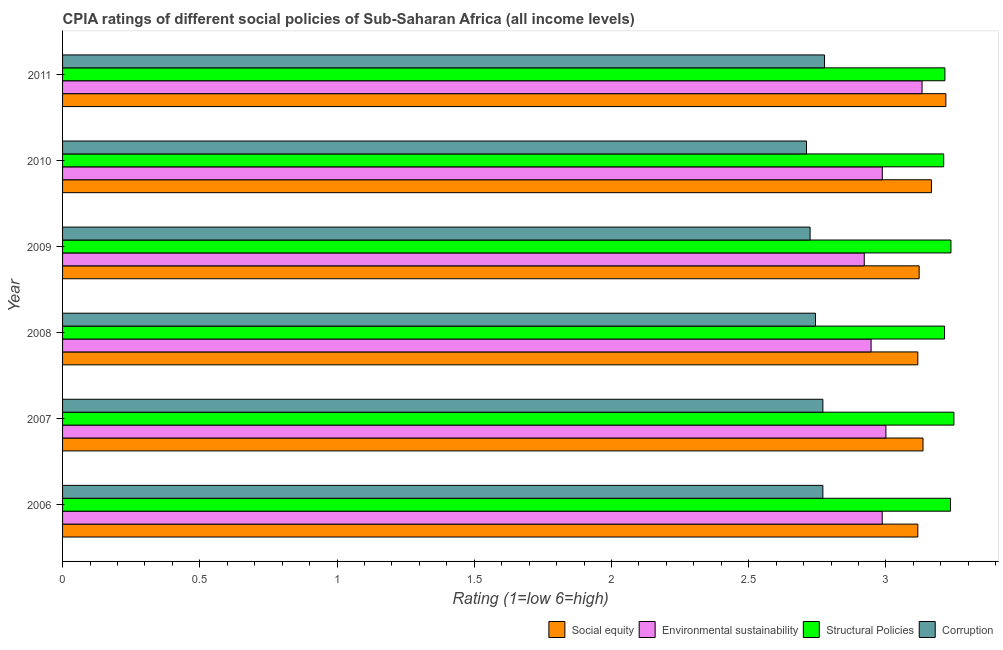How many different coloured bars are there?
Your answer should be very brief. 4. Are the number of bars per tick equal to the number of legend labels?
Provide a succinct answer. Yes. Are the number of bars on each tick of the Y-axis equal?
Give a very brief answer. Yes. How many bars are there on the 3rd tick from the bottom?
Provide a succinct answer. 4. What is the label of the 1st group of bars from the top?
Provide a short and direct response. 2011. In how many cases, is the number of bars for a given year not equal to the number of legend labels?
Your answer should be very brief. 0. What is the cpia rating of corruption in 2009?
Your response must be concise. 2.72. Across all years, what is the maximum cpia rating of social equity?
Provide a short and direct response. 3.22. Across all years, what is the minimum cpia rating of social equity?
Ensure brevity in your answer.  3.12. In which year was the cpia rating of environmental sustainability maximum?
Give a very brief answer. 2011. What is the total cpia rating of corruption in the graph?
Your answer should be very brief. 16.49. What is the difference between the cpia rating of environmental sustainability in 2010 and that in 2011?
Your response must be concise. -0.14. What is the difference between the cpia rating of structural policies in 2009 and the cpia rating of environmental sustainability in 2011?
Offer a terse response. 0.11. What is the average cpia rating of structural policies per year?
Make the answer very short. 3.23. In the year 2009, what is the difference between the cpia rating of social equity and cpia rating of corruption?
Your answer should be compact. 0.4. In how many years, is the cpia rating of corruption greater than 0.5 ?
Offer a very short reply. 6. Is the difference between the cpia rating of structural policies in 2006 and 2007 greater than the difference between the cpia rating of social equity in 2006 and 2007?
Offer a very short reply. Yes. What is the difference between the highest and the second highest cpia rating of social equity?
Ensure brevity in your answer.  0.05. What is the difference between the highest and the lowest cpia rating of social equity?
Your answer should be very brief. 0.1. Is the sum of the cpia rating of environmental sustainability in 2009 and 2011 greater than the maximum cpia rating of structural policies across all years?
Provide a succinct answer. Yes. What does the 1st bar from the top in 2010 represents?
Your response must be concise. Corruption. What does the 4th bar from the bottom in 2008 represents?
Keep it short and to the point. Corruption. How many years are there in the graph?
Provide a succinct answer. 6. What is the difference between two consecutive major ticks on the X-axis?
Your response must be concise. 0.5. Are the values on the major ticks of X-axis written in scientific E-notation?
Keep it short and to the point. No. Does the graph contain grids?
Offer a very short reply. No. Where does the legend appear in the graph?
Keep it short and to the point. Bottom right. How many legend labels are there?
Your response must be concise. 4. How are the legend labels stacked?
Your answer should be compact. Horizontal. What is the title of the graph?
Your answer should be very brief. CPIA ratings of different social policies of Sub-Saharan Africa (all income levels). What is the Rating (1=low 6=high) in Social equity in 2006?
Make the answer very short. 3.12. What is the Rating (1=low 6=high) in Environmental sustainability in 2006?
Your answer should be compact. 2.99. What is the Rating (1=low 6=high) of Structural Policies in 2006?
Make the answer very short. 3.24. What is the Rating (1=low 6=high) of Corruption in 2006?
Give a very brief answer. 2.77. What is the Rating (1=low 6=high) in Social equity in 2007?
Give a very brief answer. 3.14. What is the Rating (1=low 6=high) in Environmental sustainability in 2007?
Give a very brief answer. 3. What is the Rating (1=low 6=high) in Structural Policies in 2007?
Your answer should be compact. 3.25. What is the Rating (1=low 6=high) of Corruption in 2007?
Provide a short and direct response. 2.77. What is the Rating (1=low 6=high) in Social equity in 2008?
Provide a short and direct response. 3.12. What is the Rating (1=low 6=high) of Environmental sustainability in 2008?
Provide a short and direct response. 2.95. What is the Rating (1=low 6=high) of Structural Policies in 2008?
Offer a terse response. 3.21. What is the Rating (1=low 6=high) in Corruption in 2008?
Offer a terse response. 2.74. What is the Rating (1=low 6=high) of Social equity in 2009?
Make the answer very short. 3.12. What is the Rating (1=low 6=high) in Environmental sustainability in 2009?
Ensure brevity in your answer.  2.92. What is the Rating (1=low 6=high) in Structural Policies in 2009?
Your answer should be compact. 3.24. What is the Rating (1=low 6=high) of Corruption in 2009?
Your answer should be very brief. 2.72. What is the Rating (1=low 6=high) of Social equity in 2010?
Provide a succinct answer. 3.17. What is the Rating (1=low 6=high) in Environmental sustainability in 2010?
Your answer should be compact. 2.99. What is the Rating (1=low 6=high) of Structural Policies in 2010?
Offer a terse response. 3.21. What is the Rating (1=low 6=high) in Corruption in 2010?
Make the answer very short. 2.71. What is the Rating (1=low 6=high) in Social equity in 2011?
Your answer should be very brief. 3.22. What is the Rating (1=low 6=high) in Environmental sustainability in 2011?
Make the answer very short. 3.13. What is the Rating (1=low 6=high) of Structural Policies in 2011?
Your answer should be very brief. 3.21. What is the Rating (1=low 6=high) of Corruption in 2011?
Ensure brevity in your answer.  2.78. Across all years, what is the maximum Rating (1=low 6=high) in Social equity?
Ensure brevity in your answer.  3.22. Across all years, what is the maximum Rating (1=low 6=high) of Environmental sustainability?
Offer a terse response. 3.13. Across all years, what is the maximum Rating (1=low 6=high) in Structural Policies?
Give a very brief answer. 3.25. Across all years, what is the maximum Rating (1=low 6=high) in Corruption?
Give a very brief answer. 2.78. Across all years, what is the minimum Rating (1=low 6=high) of Social equity?
Ensure brevity in your answer.  3.12. Across all years, what is the minimum Rating (1=low 6=high) of Environmental sustainability?
Provide a short and direct response. 2.92. Across all years, what is the minimum Rating (1=low 6=high) of Structural Policies?
Offer a terse response. 3.21. Across all years, what is the minimum Rating (1=low 6=high) in Corruption?
Offer a terse response. 2.71. What is the total Rating (1=low 6=high) of Social equity in the graph?
Ensure brevity in your answer.  18.87. What is the total Rating (1=low 6=high) in Environmental sustainability in the graph?
Provide a succinct answer. 17.97. What is the total Rating (1=low 6=high) in Structural Policies in the graph?
Make the answer very short. 19.36. What is the total Rating (1=low 6=high) in Corruption in the graph?
Your response must be concise. 16.49. What is the difference between the Rating (1=low 6=high) of Social equity in 2006 and that in 2007?
Keep it short and to the point. -0.02. What is the difference between the Rating (1=low 6=high) of Environmental sustainability in 2006 and that in 2007?
Offer a very short reply. -0.01. What is the difference between the Rating (1=low 6=high) of Structural Policies in 2006 and that in 2007?
Keep it short and to the point. -0.01. What is the difference between the Rating (1=low 6=high) of Corruption in 2006 and that in 2007?
Provide a succinct answer. 0. What is the difference between the Rating (1=low 6=high) of Environmental sustainability in 2006 and that in 2008?
Offer a terse response. 0.04. What is the difference between the Rating (1=low 6=high) of Structural Policies in 2006 and that in 2008?
Provide a succinct answer. 0.02. What is the difference between the Rating (1=low 6=high) of Corruption in 2006 and that in 2008?
Keep it short and to the point. 0.03. What is the difference between the Rating (1=low 6=high) in Social equity in 2006 and that in 2009?
Your response must be concise. -0. What is the difference between the Rating (1=low 6=high) in Environmental sustainability in 2006 and that in 2009?
Offer a terse response. 0.07. What is the difference between the Rating (1=low 6=high) in Structural Policies in 2006 and that in 2009?
Your answer should be compact. -0. What is the difference between the Rating (1=low 6=high) of Corruption in 2006 and that in 2009?
Ensure brevity in your answer.  0.05. What is the difference between the Rating (1=low 6=high) of Social equity in 2006 and that in 2010?
Ensure brevity in your answer.  -0.05. What is the difference between the Rating (1=low 6=high) of Environmental sustainability in 2006 and that in 2010?
Keep it short and to the point. -0. What is the difference between the Rating (1=low 6=high) of Structural Policies in 2006 and that in 2010?
Your answer should be compact. 0.02. What is the difference between the Rating (1=low 6=high) of Corruption in 2006 and that in 2010?
Ensure brevity in your answer.  0.06. What is the difference between the Rating (1=low 6=high) of Social equity in 2006 and that in 2011?
Your response must be concise. -0.1. What is the difference between the Rating (1=low 6=high) of Environmental sustainability in 2006 and that in 2011?
Make the answer very short. -0.15. What is the difference between the Rating (1=low 6=high) in Structural Policies in 2006 and that in 2011?
Provide a short and direct response. 0.02. What is the difference between the Rating (1=low 6=high) in Corruption in 2006 and that in 2011?
Offer a terse response. -0.01. What is the difference between the Rating (1=low 6=high) of Social equity in 2007 and that in 2008?
Provide a short and direct response. 0.02. What is the difference between the Rating (1=low 6=high) of Environmental sustainability in 2007 and that in 2008?
Your response must be concise. 0.05. What is the difference between the Rating (1=low 6=high) in Structural Policies in 2007 and that in 2008?
Your response must be concise. 0.03. What is the difference between the Rating (1=low 6=high) of Corruption in 2007 and that in 2008?
Your answer should be compact. 0.03. What is the difference between the Rating (1=low 6=high) of Social equity in 2007 and that in 2009?
Ensure brevity in your answer.  0.01. What is the difference between the Rating (1=low 6=high) in Environmental sustainability in 2007 and that in 2009?
Give a very brief answer. 0.08. What is the difference between the Rating (1=low 6=high) in Structural Policies in 2007 and that in 2009?
Ensure brevity in your answer.  0.01. What is the difference between the Rating (1=low 6=high) in Corruption in 2007 and that in 2009?
Ensure brevity in your answer.  0.05. What is the difference between the Rating (1=low 6=high) of Social equity in 2007 and that in 2010?
Offer a very short reply. -0.03. What is the difference between the Rating (1=low 6=high) of Environmental sustainability in 2007 and that in 2010?
Your response must be concise. 0.01. What is the difference between the Rating (1=low 6=high) in Structural Policies in 2007 and that in 2010?
Provide a succinct answer. 0.04. What is the difference between the Rating (1=low 6=high) in Corruption in 2007 and that in 2010?
Your response must be concise. 0.06. What is the difference between the Rating (1=low 6=high) of Social equity in 2007 and that in 2011?
Offer a terse response. -0.08. What is the difference between the Rating (1=low 6=high) in Environmental sustainability in 2007 and that in 2011?
Ensure brevity in your answer.  -0.13. What is the difference between the Rating (1=low 6=high) of Structural Policies in 2007 and that in 2011?
Your response must be concise. 0.03. What is the difference between the Rating (1=low 6=high) of Corruption in 2007 and that in 2011?
Provide a succinct answer. -0.01. What is the difference between the Rating (1=low 6=high) of Social equity in 2008 and that in 2009?
Your answer should be very brief. -0. What is the difference between the Rating (1=low 6=high) of Environmental sustainability in 2008 and that in 2009?
Offer a very short reply. 0.02. What is the difference between the Rating (1=low 6=high) in Structural Policies in 2008 and that in 2009?
Offer a terse response. -0.02. What is the difference between the Rating (1=low 6=high) of Corruption in 2008 and that in 2009?
Keep it short and to the point. 0.02. What is the difference between the Rating (1=low 6=high) of Social equity in 2008 and that in 2010?
Offer a terse response. -0.05. What is the difference between the Rating (1=low 6=high) of Environmental sustainability in 2008 and that in 2010?
Give a very brief answer. -0.04. What is the difference between the Rating (1=low 6=high) of Structural Policies in 2008 and that in 2010?
Keep it short and to the point. 0. What is the difference between the Rating (1=low 6=high) in Corruption in 2008 and that in 2010?
Give a very brief answer. 0.03. What is the difference between the Rating (1=low 6=high) of Social equity in 2008 and that in 2011?
Ensure brevity in your answer.  -0.1. What is the difference between the Rating (1=low 6=high) in Environmental sustainability in 2008 and that in 2011?
Provide a short and direct response. -0.19. What is the difference between the Rating (1=low 6=high) in Structural Policies in 2008 and that in 2011?
Give a very brief answer. -0. What is the difference between the Rating (1=low 6=high) in Corruption in 2008 and that in 2011?
Offer a very short reply. -0.03. What is the difference between the Rating (1=low 6=high) in Social equity in 2009 and that in 2010?
Your response must be concise. -0.04. What is the difference between the Rating (1=low 6=high) of Environmental sustainability in 2009 and that in 2010?
Offer a very short reply. -0.07. What is the difference between the Rating (1=low 6=high) of Structural Policies in 2009 and that in 2010?
Ensure brevity in your answer.  0.03. What is the difference between the Rating (1=low 6=high) of Corruption in 2009 and that in 2010?
Keep it short and to the point. 0.01. What is the difference between the Rating (1=low 6=high) of Social equity in 2009 and that in 2011?
Provide a succinct answer. -0.1. What is the difference between the Rating (1=low 6=high) in Environmental sustainability in 2009 and that in 2011?
Your answer should be very brief. -0.21. What is the difference between the Rating (1=low 6=high) in Structural Policies in 2009 and that in 2011?
Your answer should be compact. 0.02. What is the difference between the Rating (1=low 6=high) in Corruption in 2009 and that in 2011?
Your answer should be compact. -0.05. What is the difference between the Rating (1=low 6=high) in Social equity in 2010 and that in 2011?
Your response must be concise. -0.05. What is the difference between the Rating (1=low 6=high) in Environmental sustainability in 2010 and that in 2011?
Provide a short and direct response. -0.14. What is the difference between the Rating (1=low 6=high) in Structural Policies in 2010 and that in 2011?
Give a very brief answer. -0. What is the difference between the Rating (1=low 6=high) of Corruption in 2010 and that in 2011?
Give a very brief answer. -0.07. What is the difference between the Rating (1=low 6=high) in Social equity in 2006 and the Rating (1=low 6=high) in Environmental sustainability in 2007?
Provide a short and direct response. 0.12. What is the difference between the Rating (1=low 6=high) of Social equity in 2006 and the Rating (1=low 6=high) of Structural Policies in 2007?
Ensure brevity in your answer.  -0.13. What is the difference between the Rating (1=low 6=high) of Social equity in 2006 and the Rating (1=low 6=high) of Corruption in 2007?
Ensure brevity in your answer.  0.35. What is the difference between the Rating (1=low 6=high) in Environmental sustainability in 2006 and the Rating (1=low 6=high) in Structural Policies in 2007?
Your answer should be very brief. -0.26. What is the difference between the Rating (1=low 6=high) in Environmental sustainability in 2006 and the Rating (1=low 6=high) in Corruption in 2007?
Provide a short and direct response. 0.22. What is the difference between the Rating (1=low 6=high) in Structural Policies in 2006 and the Rating (1=low 6=high) in Corruption in 2007?
Give a very brief answer. 0.46. What is the difference between the Rating (1=low 6=high) of Social equity in 2006 and the Rating (1=low 6=high) of Environmental sustainability in 2008?
Offer a very short reply. 0.17. What is the difference between the Rating (1=low 6=high) of Social equity in 2006 and the Rating (1=low 6=high) of Structural Policies in 2008?
Your answer should be compact. -0.1. What is the difference between the Rating (1=low 6=high) of Social equity in 2006 and the Rating (1=low 6=high) of Corruption in 2008?
Ensure brevity in your answer.  0.37. What is the difference between the Rating (1=low 6=high) of Environmental sustainability in 2006 and the Rating (1=low 6=high) of Structural Policies in 2008?
Ensure brevity in your answer.  -0.23. What is the difference between the Rating (1=low 6=high) in Environmental sustainability in 2006 and the Rating (1=low 6=high) in Corruption in 2008?
Your answer should be very brief. 0.24. What is the difference between the Rating (1=low 6=high) of Structural Policies in 2006 and the Rating (1=low 6=high) of Corruption in 2008?
Provide a succinct answer. 0.49. What is the difference between the Rating (1=low 6=high) in Social equity in 2006 and the Rating (1=low 6=high) in Environmental sustainability in 2009?
Ensure brevity in your answer.  0.2. What is the difference between the Rating (1=low 6=high) in Social equity in 2006 and the Rating (1=low 6=high) in Structural Policies in 2009?
Ensure brevity in your answer.  -0.12. What is the difference between the Rating (1=low 6=high) of Social equity in 2006 and the Rating (1=low 6=high) of Corruption in 2009?
Give a very brief answer. 0.39. What is the difference between the Rating (1=low 6=high) in Environmental sustainability in 2006 and the Rating (1=low 6=high) in Structural Policies in 2009?
Ensure brevity in your answer.  -0.25. What is the difference between the Rating (1=low 6=high) of Environmental sustainability in 2006 and the Rating (1=low 6=high) of Corruption in 2009?
Ensure brevity in your answer.  0.26. What is the difference between the Rating (1=low 6=high) of Structural Policies in 2006 and the Rating (1=low 6=high) of Corruption in 2009?
Offer a very short reply. 0.51. What is the difference between the Rating (1=low 6=high) in Social equity in 2006 and the Rating (1=low 6=high) in Environmental sustainability in 2010?
Keep it short and to the point. 0.13. What is the difference between the Rating (1=low 6=high) of Social equity in 2006 and the Rating (1=low 6=high) of Structural Policies in 2010?
Make the answer very short. -0.09. What is the difference between the Rating (1=low 6=high) of Social equity in 2006 and the Rating (1=low 6=high) of Corruption in 2010?
Your answer should be compact. 0.41. What is the difference between the Rating (1=low 6=high) of Environmental sustainability in 2006 and the Rating (1=low 6=high) of Structural Policies in 2010?
Ensure brevity in your answer.  -0.22. What is the difference between the Rating (1=low 6=high) in Environmental sustainability in 2006 and the Rating (1=low 6=high) in Corruption in 2010?
Give a very brief answer. 0.28. What is the difference between the Rating (1=low 6=high) of Structural Policies in 2006 and the Rating (1=low 6=high) of Corruption in 2010?
Your answer should be compact. 0.52. What is the difference between the Rating (1=low 6=high) in Social equity in 2006 and the Rating (1=low 6=high) in Environmental sustainability in 2011?
Your response must be concise. -0.02. What is the difference between the Rating (1=low 6=high) of Social equity in 2006 and the Rating (1=low 6=high) of Structural Policies in 2011?
Make the answer very short. -0.1. What is the difference between the Rating (1=low 6=high) in Social equity in 2006 and the Rating (1=low 6=high) in Corruption in 2011?
Ensure brevity in your answer.  0.34. What is the difference between the Rating (1=low 6=high) of Environmental sustainability in 2006 and the Rating (1=low 6=high) of Structural Policies in 2011?
Keep it short and to the point. -0.23. What is the difference between the Rating (1=low 6=high) in Environmental sustainability in 2006 and the Rating (1=low 6=high) in Corruption in 2011?
Offer a terse response. 0.21. What is the difference between the Rating (1=low 6=high) in Structural Policies in 2006 and the Rating (1=low 6=high) in Corruption in 2011?
Provide a short and direct response. 0.46. What is the difference between the Rating (1=low 6=high) of Social equity in 2007 and the Rating (1=low 6=high) of Environmental sustainability in 2008?
Offer a terse response. 0.19. What is the difference between the Rating (1=low 6=high) in Social equity in 2007 and the Rating (1=low 6=high) in Structural Policies in 2008?
Provide a succinct answer. -0.08. What is the difference between the Rating (1=low 6=high) of Social equity in 2007 and the Rating (1=low 6=high) of Corruption in 2008?
Provide a succinct answer. 0.39. What is the difference between the Rating (1=low 6=high) of Environmental sustainability in 2007 and the Rating (1=low 6=high) of Structural Policies in 2008?
Keep it short and to the point. -0.21. What is the difference between the Rating (1=low 6=high) of Environmental sustainability in 2007 and the Rating (1=low 6=high) of Corruption in 2008?
Your response must be concise. 0.26. What is the difference between the Rating (1=low 6=high) of Structural Policies in 2007 and the Rating (1=low 6=high) of Corruption in 2008?
Provide a succinct answer. 0.5. What is the difference between the Rating (1=low 6=high) in Social equity in 2007 and the Rating (1=low 6=high) in Environmental sustainability in 2009?
Your answer should be compact. 0.21. What is the difference between the Rating (1=low 6=high) in Social equity in 2007 and the Rating (1=low 6=high) in Structural Policies in 2009?
Your answer should be compact. -0.1. What is the difference between the Rating (1=low 6=high) of Social equity in 2007 and the Rating (1=low 6=high) of Corruption in 2009?
Your answer should be compact. 0.41. What is the difference between the Rating (1=low 6=high) of Environmental sustainability in 2007 and the Rating (1=low 6=high) of Structural Policies in 2009?
Your answer should be very brief. -0.24. What is the difference between the Rating (1=low 6=high) of Environmental sustainability in 2007 and the Rating (1=low 6=high) of Corruption in 2009?
Your answer should be very brief. 0.28. What is the difference between the Rating (1=low 6=high) of Structural Policies in 2007 and the Rating (1=low 6=high) of Corruption in 2009?
Offer a very short reply. 0.52. What is the difference between the Rating (1=low 6=high) in Social equity in 2007 and the Rating (1=low 6=high) in Environmental sustainability in 2010?
Your response must be concise. 0.15. What is the difference between the Rating (1=low 6=high) in Social equity in 2007 and the Rating (1=low 6=high) in Structural Policies in 2010?
Provide a short and direct response. -0.08. What is the difference between the Rating (1=low 6=high) in Social equity in 2007 and the Rating (1=low 6=high) in Corruption in 2010?
Make the answer very short. 0.42. What is the difference between the Rating (1=low 6=high) in Environmental sustainability in 2007 and the Rating (1=low 6=high) in Structural Policies in 2010?
Keep it short and to the point. -0.21. What is the difference between the Rating (1=low 6=high) of Environmental sustainability in 2007 and the Rating (1=low 6=high) of Corruption in 2010?
Ensure brevity in your answer.  0.29. What is the difference between the Rating (1=low 6=high) in Structural Policies in 2007 and the Rating (1=low 6=high) in Corruption in 2010?
Offer a very short reply. 0.54. What is the difference between the Rating (1=low 6=high) in Social equity in 2007 and the Rating (1=low 6=high) in Environmental sustainability in 2011?
Make the answer very short. 0. What is the difference between the Rating (1=low 6=high) in Social equity in 2007 and the Rating (1=low 6=high) in Structural Policies in 2011?
Give a very brief answer. -0.08. What is the difference between the Rating (1=low 6=high) in Social equity in 2007 and the Rating (1=low 6=high) in Corruption in 2011?
Your answer should be very brief. 0.36. What is the difference between the Rating (1=low 6=high) in Environmental sustainability in 2007 and the Rating (1=low 6=high) in Structural Policies in 2011?
Offer a very short reply. -0.21. What is the difference between the Rating (1=low 6=high) of Environmental sustainability in 2007 and the Rating (1=low 6=high) of Corruption in 2011?
Provide a short and direct response. 0.22. What is the difference between the Rating (1=low 6=high) in Structural Policies in 2007 and the Rating (1=low 6=high) in Corruption in 2011?
Give a very brief answer. 0.47. What is the difference between the Rating (1=low 6=high) in Social equity in 2008 and the Rating (1=low 6=high) in Environmental sustainability in 2009?
Offer a terse response. 0.2. What is the difference between the Rating (1=low 6=high) in Social equity in 2008 and the Rating (1=low 6=high) in Structural Policies in 2009?
Offer a terse response. -0.12. What is the difference between the Rating (1=low 6=high) in Social equity in 2008 and the Rating (1=low 6=high) in Corruption in 2009?
Provide a succinct answer. 0.39. What is the difference between the Rating (1=low 6=high) in Environmental sustainability in 2008 and the Rating (1=low 6=high) in Structural Policies in 2009?
Your answer should be very brief. -0.29. What is the difference between the Rating (1=low 6=high) of Environmental sustainability in 2008 and the Rating (1=low 6=high) of Corruption in 2009?
Give a very brief answer. 0.22. What is the difference between the Rating (1=low 6=high) of Structural Policies in 2008 and the Rating (1=low 6=high) of Corruption in 2009?
Make the answer very short. 0.49. What is the difference between the Rating (1=low 6=high) in Social equity in 2008 and the Rating (1=low 6=high) in Environmental sustainability in 2010?
Ensure brevity in your answer.  0.13. What is the difference between the Rating (1=low 6=high) in Social equity in 2008 and the Rating (1=low 6=high) in Structural Policies in 2010?
Offer a terse response. -0.09. What is the difference between the Rating (1=low 6=high) of Social equity in 2008 and the Rating (1=low 6=high) of Corruption in 2010?
Your response must be concise. 0.41. What is the difference between the Rating (1=low 6=high) in Environmental sustainability in 2008 and the Rating (1=low 6=high) in Structural Policies in 2010?
Your answer should be very brief. -0.26. What is the difference between the Rating (1=low 6=high) in Environmental sustainability in 2008 and the Rating (1=low 6=high) in Corruption in 2010?
Give a very brief answer. 0.24. What is the difference between the Rating (1=low 6=high) in Structural Policies in 2008 and the Rating (1=low 6=high) in Corruption in 2010?
Your answer should be compact. 0.5. What is the difference between the Rating (1=low 6=high) of Social equity in 2008 and the Rating (1=low 6=high) of Environmental sustainability in 2011?
Keep it short and to the point. -0.02. What is the difference between the Rating (1=low 6=high) of Social equity in 2008 and the Rating (1=low 6=high) of Structural Policies in 2011?
Offer a very short reply. -0.1. What is the difference between the Rating (1=low 6=high) in Social equity in 2008 and the Rating (1=low 6=high) in Corruption in 2011?
Your response must be concise. 0.34. What is the difference between the Rating (1=low 6=high) in Environmental sustainability in 2008 and the Rating (1=low 6=high) in Structural Policies in 2011?
Provide a short and direct response. -0.27. What is the difference between the Rating (1=low 6=high) in Environmental sustainability in 2008 and the Rating (1=low 6=high) in Corruption in 2011?
Ensure brevity in your answer.  0.17. What is the difference between the Rating (1=low 6=high) in Structural Policies in 2008 and the Rating (1=low 6=high) in Corruption in 2011?
Offer a terse response. 0.44. What is the difference between the Rating (1=low 6=high) of Social equity in 2009 and the Rating (1=low 6=high) of Environmental sustainability in 2010?
Your response must be concise. 0.13. What is the difference between the Rating (1=low 6=high) of Social equity in 2009 and the Rating (1=low 6=high) of Structural Policies in 2010?
Provide a short and direct response. -0.09. What is the difference between the Rating (1=low 6=high) of Social equity in 2009 and the Rating (1=low 6=high) of Corruption in 2010?
Provide a succinct answer. 0.41. What is the difference between the Rating (1=low 6=high) in Environmental sustainability in 2009 and the Rating (1=low 6=high) in Structural Policies in 2010?
Provide a succinct answer. -0.29. What is the difference between the Rating (1=low 6=high) of Environmental sustainability in 2009 and the Rating (1=low 6=high) of Corruption in 2010?
Your response must be concise. 0.21. What is the difference between the Rating (1=low 6=high) of Structural Policies in 2009 and the Rating (1=low 6=high) of Corruption in 2010?
Provide a succinct answer. 0.53. What is the difference between the Rating (1=low 6=high) in Social equity in 2009 and the Rating (1=low 6=high) in Environmental sustainability in 2011?
Make the answer very short. -0.01. What is the difference between the Rating (1=low 6=high) of Social equity in 2009 and the Rating (1=low 6=high) of Structural Policies in 2011?
Your answer should be compact. -0.09. What is the difference between the Rating (1=low 6=high) in Social equity in 2009 and the Rating (1=low 6=high) in Corruption in 2011?
Offer a terse response. 0.34. What is the difference between the Rating (1=low 6=high) in Environmental sustainability in 2009 and the Rating (1=low 6=high) in Structural Policies in 2011?
Your answer should be very brief. -0.29. What is the difference between the Rating (1=low 6=high) in Environmental sustainability in 2009 and the Rating (1=low 6=high) in Corruption in 2011?
Your answer should be very brief. 0.14. What is the difference between the Rating (1=low 6=high) in Structural Policies in 2009 and the Rating (1=low 6=high) in Corruption in 2011?
Provide a succinct answer. 0.46. What is the difference between the Rating (1=low 6=high) of Social equity in 2010 and the Rating (1=low 6=high) of Environmental sustainability in 2011?
Offer a very short reply. 0.03. What is the difference between the Rating (1=low 6=high) of Social equity in 2010 and the Rating (1=low 6=high) of Structural Policies in 2011?
Provide a succinct answer. -0.05. What is the difference between the Rating (1=low 6=high) in Social equity in 2010 and the Rating (1=low 6=high) in Corruption in 2011?
Provide a short and direct response. 0.39. What is the difference between the Rating (1=low 6=high) of Environmental sustainability in 2010 and the Rating (1=low 6=high) of Structural Policies in 2011?
Provide a short and direct response. -0.23. What is the difference between the Rating (1=low 6=high) of Environmental sustainability in 2010 and the Rating (1=low 6=high) of Corruption in 2011?
Provide a succinct answer. 0.21. What is the difference between the Rating (1=low 6=high) of Structural Policies in 2010 and the Rating (1=low 6=high) of Corruption in 2011?
Ensure brevity in your answer.  0.43. What is the average Rating (1=low 6=high) in Social equity per year?
Your response must be concise. 3.15. What is the average Rating (1=low 6=high) of Environmental sustainability per year?
Provide a short and direct response. 3. What is the average Rating (1=low 6=high) of Structural Policies per year?
Provide a succinct answer. 3.23. What is the average Rating (1=low 6=high) of Corruption per year?
Your answer should be compact. 2.75. In the year 2006, what is the difference between the Rating (1=low 6=high) in Social equity and Rating (1=low 6=high) in Environmental sustainability?
Offer a terse response. 0.13. In the year 2006, what is the difference between the Rating (1=low 6=high) in Social equity and Rating (1=low 6=high) in Structural Policies?
Give a very brief answer. -0.12. In the year 2006, what is the difference between the Rating (1=low 6=high) in Social equity and Rating (1=low 6=high) in Corruption?
Your response must be concise. 0.35. In the year 2006, what is the difference between the Rating (1=low 6=high) of Environmental sustainability and Rating (1=low 6=high) of Structural Policies?
Your response must be concise. -0.25. In the year 2006, what is the difference between the Rating (1=low 6=high) in Environmental sustainability and Rating (1=low 6=high) in Corruption?
Provide a succinct answer. 0.22. In the year 2006, what is the difference between the Rating (1=low 6=high) of Structural Policies and Rating (1=low 6=high) of Corruption?
Provide a short and direct response. 0.46. In the year 2007, what is the difference between the Rating (1=low 6=high) in Social equity and Rating (1=low 6=high) in Environmental sustainability?
Offer a terse response. 0.14. In the year 2007, what is the difference between the Rating (1=low 6=high) in Social equity and Rating (1=low 6=high) in Structural Policies?
Your answer should be very brief. -0.11. In the year 2007, what is the difference between the Rating (1=low 6=high) in Social equity and Rating (1=low 6=high) in Corruption?
Provide a succinct answer. 0.36. In the year 2007, what is the difference between the Rating (1=low 6=high) in Environmental sustainability and Rating (1=low 6=high) in Structural Policies?
Ensure brevity in your answer.  -0.25. In the year 2007, what is the difference between the Rating (1=low 6=high) in Environmental sustainability and Rating (1=low 6=high) in Corruption?
Your answer should be compact. 0.23. In the year 2007, what is the difference between the Rating (1=low 6=high) of Structural Policies and Rating (1=low 6=high) of Corruption?
Keep it short and to the point. 0.48. In the year 2008, what is the difference between the Rating (1=low 6=high) of Social equity and Rating (1=low 6=high) of Environmental sustainability?
Provide a short and direct response. 0.17. In the year 2008, what is the difference between the Rating (1=low 6=high) of Social equity and Rating (1=low 6=high) of Structural Policies?
Give a very brief answer. -0.1. In the year 2008, what is the difference between the Rating (1=low 6=high) in Social equity and Rating (1=low 6=high) in Corruption?
Give a very brief answer. 0.37. In the year 2008, what is the difference between the Rating (1=low 6=high) in Environmental sustainability and Rating (1=low 6=high) in Structural Policies?
Provide a short and direct response. -0.27. In the year 2008, what is the difference between the Rating (1=low 6=high) of Environmental sustainability and Rating (1=low 6=high) of Corruption?
Provide a short and direct response. 0.2. In the year 2008, what is the difference between the Rating (1=low 6=high) of Structural Policies and Rating (1=low 6=high) of Corruption?
Provide a succinct answer. 0.47. In the year 2009, what is the difference between the Rating (1=low 6=high) of Social equity and Rating (1=low 6=high) of Environmental sustainability?
Your response must be concise. 0.2. In the year 2009, what is the difference between the Rating (1=low 6=high) of Social equity and Rating (1=low 6=high) of Structural Policies?
Your answer should be compact. -0.12. In the year 2009, what is the difference between the Rating (1=low 6=high) in Social equity and Rating (1=low 6=high) in Corruption?
Provide a short and direct response. 0.4. In the year 2009, what is the difference between the Rating (1=low 6=high) in Environmental sustainability and Rating (1=low 6=high) in Structural Policies?
Provide a short and direct response. -0.32. In the year 2009, what is the difference between the Rating (1=low 6=high) of Environmental sustainability and Rating (1=low 6=high) of Corruption?
Give a very brief answer. 0.2. In the year 2009, what is the difference between the Rating (1=low 6=high) in Structural Policies and Rating (1=low 6=high) in Corruption?
Make the answer very short. 0.51. In the year 2010, what is the difference between the Rating (1=low 6=high) in Social equity and Rating (1=low 6=high) in Environmental sustainability?
Your answer should be very brief. 0.18. In the year 2010, what is the difference between the Rating (1=low 6=high) of Social equity and Rating (1=low 6=high) of Structural Policies?
Offer a very short reply. -0.04. In the year 2010, what is the difference between the Rating (1=low 6=high) in Social equity and Rating (1=low 6=high) in Corruption?
Your answer should be very brief. 0.46. In the year 2010, what is the difference between the Rating (1=low 6=high) of Environmental sustainability and Rating (1=low 6=high) of Structural Policies?
Provide a succinct answer. -0.22. In the year 2010, what is the difference between the Rating (1=low 6=high) of Environmental sustainability and Rating (1=low 6=high) of Corruption?
Your response must be concise. 0.28. In the year 2010, what is the difference between the Rating (1=low 6=high) of Structural Policies and Rating (1=low 6=high) of Corruption?
Keep it short and to the point. 0.5. In the year 2011, what is the difference between the Rating (1=low 6=high) in Social equity and Rating (1=low 6=high) in Environmental sustainability?
Provide a short and direct response. 0.09. In the year 2011, what is the difference between the Rating (1=low 6=high) of Social equity and Rating (1=low 6=high) of Structural Policies?
Keep it short and to the point. 0. In the year 2011, what is the difference between the Rating (1=low 6=high) in Social equity and Rating (1=low 6=high) in Corruption?
Give a very brief answer. 0.44. In the year 2011, what is the difference between the Rating (1=low 6=high) of Environmental sustainability and Rating (1=low 6=high) of Structural Policies?
Ensure brevity in your answer.  -0.08. In the year 2011, what is the difference between the Rating (1=low 6=high) of Environmental sustainability and Rating (1=low 6=high) of Corruption?
Your answer should be very brief. 0.36. In the year 2011, what is the difference between the Rating (1=low 6=high) in Structural Policies and Rating (1=low 6=high) in Corruption?
Offer a terse response. 0.44. What is the ratio of the Rating (1=low 6=high) of Structural Policies in 2006 to that in 2007?
Provide a short and direct response. 1. What is the ratio of the Rating (1=low 6=high) in Corruption in 2006 to that in 2007?
Ensure brevity in your answer.  1. What is the ratio of the Rating (1=low 6=high) in Social equity in 2006 to that in 2008?
Ensure brevity in your answer.  1. What is the ratio of the Rating (1=low 6=high) in Environmental sustainability in 2006 to that in 2008?
Your response must be concise. 1.01. What is the ratio of the Rating (1=low 6=high) of Structural Policies in 2006 to that in 2008?
Your response must be concise. 1.01. What is the ratio of the Rating (1=low 6=high) of Corruption in 2006 to that in 2008?
Your response must be concise. 1.01. What is the ratio of the Rating (1=low 6=high) in Social equity in 2006 to that in 2009?
Your answer should be very brief. 1. What is the ratio of the Rating (1=low 6=high) in Environmental sustainability in 2006 to that in 2009?
Your answer should be very brief. 1.02. What is the ratio of the Rating (1=low 6=high) of Corruption in 2006 to that in 2009?
Your answer should be compact. 1.02. What is the ratio of the Rating (1=low 6=high) in Social equity in 2006 to that in 2010?
Provide a short and direct response. 0.98. What is the ratio of the Rating (1=low 6=high) of Structural Policies in 2006 to that in 2010?
Make the answer very short. 1.01. What is the ratio of the Rating (1=low 6=high) in Corruption in 2006 to that in 2010?
Your answer should be very brief. 1.02. What is the ratio of the Rating (1=low 6=high) of Social equity in 2006 to that in 2011?
Keep it short and to the point. 0.97. What is the ratio of the Rating (1=low 6=high) in Environmental sustainability in 2006 to that in 2011?
Give a very brief answer. 0.95. What is the ratio of the Rating (1=low 6=high) of Structural Policies in 2006 to that in 2011?
Make the answer very short. 1.01. What is the ratio of the Rating (1=low 6=high) in Social equity in 2007 to that in 2008?
Keep it short and to the point. 1.01. What is the ratio of the Rating (1=low 6=high) of Environmental sustainability in 2007 to that in 2008?
Your answer should be very brief. 1.02. What is the ratio of the Rating (1=low 6=high) of Structural Policies in 2007 to that in 2008?
Make the answer very short. 1.01. What is the ratio of the Rating (1=low 6=high) in Corruption in 2007 to that in 2008?
Provide a succinct answer. 1.01. What is the ratio of the Rating (1=low 6=high) of Social equity in 2007 to that in 2009?
Give a very brief answer. 1. What is the ratio of the Rating (1=low 6=high) in Corruption in 2007 to that in 2009?
Offer a very short reply. 1.02. What is the ratio of the Rating (1=low 6=high) of Social equity in 2007 to that in 2010?
Ensure brevity in your answer.  0.99. What is the ratio of the Rating (1=low 6=high) in Environmental sustainability in 2007 to that in 2010?
Ensure brevity in your answer.  1. What is the ratio of the Rating (1=low 6=high) in Structural Policies in 2007 to that in 2010?
Make the answer very short. 1.01. What is the ratio of the Rating (1=low 6=high) in Corruption in 2007 to that in 2010?
Keep it short and to the point. 1.02. What is the ratio of the Rating (1=low 6=high) in Social equity in 2007 to that in 2011?
Your answer should be compact. 0.97. What is the ratio of the Rating (1=low 6=high) in Environmental sustainability in 2007 to that in 2011?
Your answer should be very brief. 0.96. What is the ratio of the Rating (1=low 6=high) of Structural Policies in 2007 to that in 2011?
Provide a succinct answer. 1.01. What is the ratio of the Rating (1=low 6=high) of Corruption in 2007 to that in 2011?
Your answer should be very brief. 1. What is the ratio of the Rating (1=low 6=high) of Social equity in 2008 to that in 2009?
Ensure brevity in your answer.  1. What is the ratio of the Rating (1=low 6=high) in Environmental sustainability in 2008 to that in 2009?
Make the answer very short. 1.01. What is the ratio of the Rating (1=low 6=high) of Structural Policies in 2008 to that in 2009?
Make the answer very short. 0.99. What is the ratio of the Rating (1=low 6=high) in Social equity in 2008 to that in 2010?
Provide a succinct answer. 0.98. What is the ratio of the Rating (1=low 6=high) of Environmental sustainability in 2008 to that in 2010?
Keep it short and to the point. 0.99. What is the ratio of the Rating (1=low 6=high) of Corruption in 2008 to that in 2010?
Offer a terse response. 1.01. What is the ratio of the Rating (1=low 6=high) of Social equity in 2008 to that in 2011?
Your response must be concise. 0.97. What is the ratio of the Rating (1=low 6=high) of Environmental sustainability in 2008 to that in 2011?
Make the answer very short. 0.94. What is the ratio of the Rating (1=low 6=high) in Structural Policies in 2008 to that in 2011?
Your answer should be very brief. 1. What is the ratio of the Rating (1=low 6=high) in Corruption in 2008 to that in 2011?
Ensure brevity in your answer.  0.99. What is the ratio of the Rating (1=low 6=high) in Social equity in 2009 to that in 2010?
Offer a very short reply. 0.99. What is the ratio of the Rating (1=low 6=high) of Structural Policies in 2009 to that in 2010?
Ensure brevity in your answer.  1.01. What is the ratio of the Rating (1=low 6=high) in Social equity in 2009 to that in 2011?
Your response must be concise. 0.97. What is the ratio of the Rating (1=low 6=high) of Environmental sustainability in 2009 to that in 2011?
Give a very brief answer. 0.93. What is the ratio of the Rating (1=low 6=high) of Structural Policies in 2009 to that in 2011?
Keep it short and to the point. 1.01. What is the ratio of the Rating (1=low 6=high) of Corruption in 2009 to that in 2011?
Your response must be concise. 0.98. What is the ratio of the Rating (1=low 6=high) of Social equity in 2010 to that in 2011?
Offer a very short reply. 0.98. What is the ratio of the Rating (1=low 6=high) of Environmental sustainability in 2010 to that in 2011?
Ensure brevity in your answer.  0.95. What is the ratio of the Rating (1=low 6=high) of Corruption in 2010 to that in 2011?
Your response must be concise. 0.98. What is the difference between the highest and the second highest Rating (1=low 6=high) of Social equity?
Your answer should be compact. 0.05. What is the difference between the highest and the second highest Rating (1=low 6=high) of Environmental sustainability?
Your answer should be very brief. 0.13. What is the difference between the highest and the second highest Rating (1=low 6=high) of Structural Policies?
Offer a very short reply. 0.01. What is the difference between the highest and the second highest Rating (1=low 6=high) in Corruption?
Make the answer very short. 0.01. What is the difference between the highest and the lowest Rating (1=low 6=high) in Social equity?
Offer a very short reply. 0.1. What is the difference between the highest and the lowest Rating (1=low 6=high) in Environmental sustainability?
Ensure brevity in your answer.  0.21. What is the difference between the highest and the lowest Rating (1=low 6=high) in Structural Policies?
Make the answer very short. 0.04. What is the difference between the highest and the lowest Rating (1=low 6=high) of Corruption?
Your response must be concise. 0.07. 